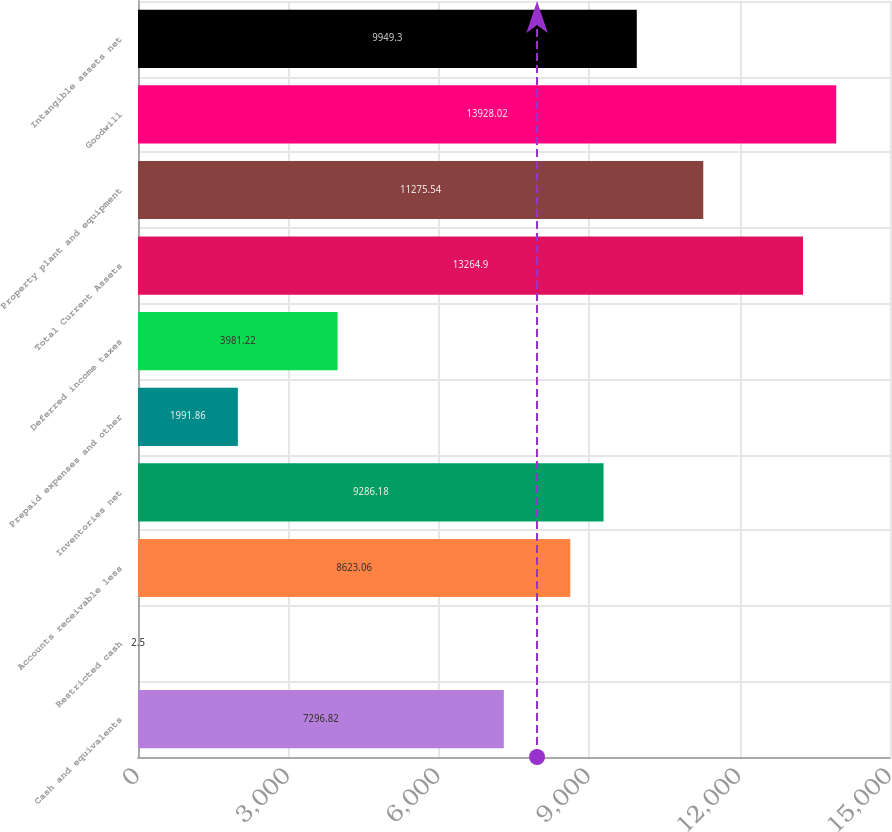Convert chart to OTSL. <chart><loc_0><loc_0><loc_500><loc_500><bar_chart><fcel>Cash and equivalents<fcel>Restricted cash<fcel>Accounts receivable less<fcel>Inventories net<fcel>Prepaid expenses and other<fcel>Deferred income taxes<fcel>Total Current Assets<fcel>Property plant and equipment<fcel>Goodwill<fcel>Intangible assets net<nl><fcel>7296.82<fcel>2.5<fcel>8623.06<fcel>9286.18<fcel>1991.86<fcel>3981.22<fcel>13264.9<fcel>11275.5<fcel>13928<fcel>9949.3<nl></chart> 